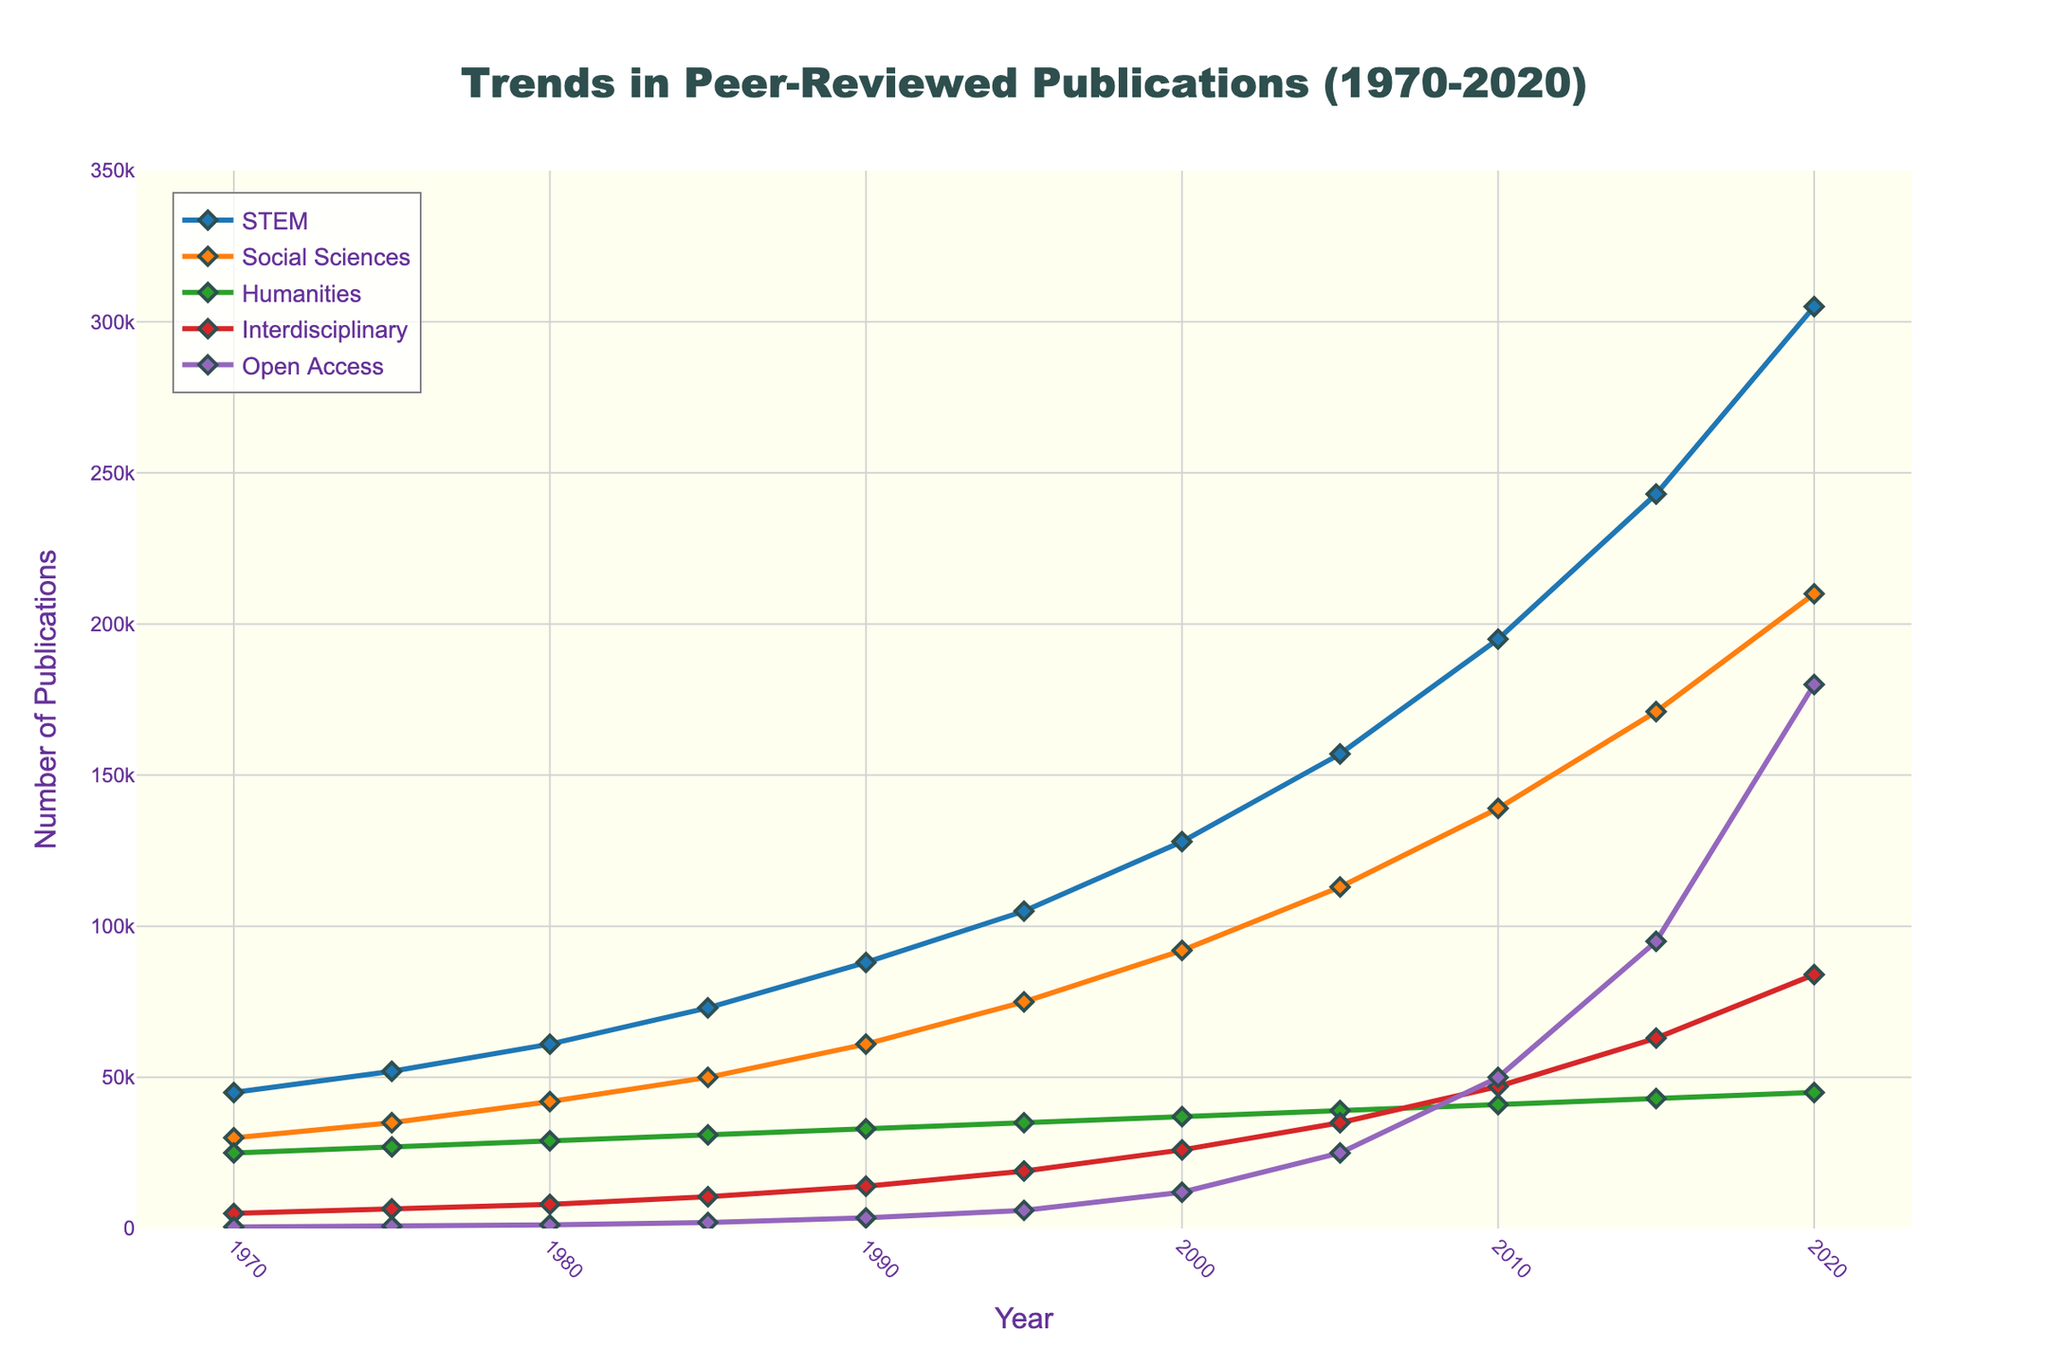What's the general trend for STEM publications from 1970 to 2020? We observe the line corresponding to STEM publications from 1970 to 2020. It shows a consistent upward trend without any noticeable declines, indicating a steady increase in the number of STEM publications over the 50-year period.
Answer: Upward trend How many more publications were there in Social Sciences in 2020 compared to 1970? We find the number of Social Sciences publications in 1970 (30,000) and 2020 (210,000). Subtract the former from the latter: 210,000 - 30,000 = 180,000.
Answer: 180,000 In which year do Open Access publications surpass Humanities publications? Look at the intersection point between the Open Access and Humanities lines. This occurs around the year 2010.
Answer: 2010 Which discipline shows the most rapid growth over the past 50 years? We identify the starting and ending points for each discipline's trend line, then estimate the growth. STEM starts at 45,000 in 1970 and ends at 305,000 in 2020, a growth of 260,000. We compare this with other disciplines.
Answer: Open Access How does the number of Interdisciplinary publications in 2000 compare to Humanities publications in the same year? We locate the points for Interdisciplinary (26,000) and Humanities (37,000) in 2000. Humanities publications are higher than Interdisciplinary publications by 11,000.
Answer: Humanities has 11,000 more What's the difference in the number of STEM and Open Access publications in 2015? Locate the points for STEM (243,000) and Open Access (95,000) in 2015. Subtract the latter from the former: 243,000 - 95,000 = 148,000.
Answer: 148,000 What's the average number of Humanities publications from 1970 to 2020? The Humanities publications for each year are: 25,000, 27,000, 29,000, 31,000, 33,000, 35,000, 37,000, 39,000, 41,000, 43,000, 45,000. Find the sum: 25,000 + 27,000 + 29,000 + 31,000 + 33,000 + 35,000 + 37,000 + 39,000 + 41,000 + 43,000 + 45,000 = 385,000. Divide by 11 (number of data points): 385,000 / 11 ≈ 35,000.
Answer: 35,000 Between 1980 and 2000, which discipline experienced the smallest percentage increase in publications? Calculate the percentage increase for each discipline from 1980 to 2000. STEM: ((128,000 - 61,000) / 61,000) * 100 ≈ 110%. Social Sciences: ((92,000 - 42,000) / 42,000) * 100 ≈ 119%. Humanities: ((37,000 - 29,000) / 29,000) * 100 ≈ 28%. Interdisciplinary: ((26,000 - 8,000) / 8,000) * 100 ≈ 225%. Open Access: ((12,000 - 1,200) / 1,200) * 100 ≈ 900%.
Answer: Humanities What visual cue indicates rapid growth in Open Access publications post-2005? Observe the slope of the line representing Open Access publications. Post-2005, the slope becomes much steeper, indicating a significant increase in the rate of publications.
Answer: Steeper slope 